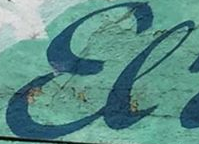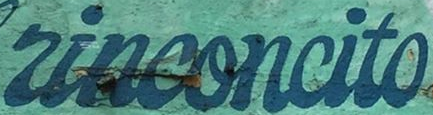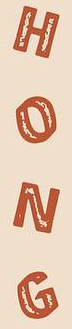Read the text from these images in sequence, separated by a semicolon. El; rinconcito; HONG 